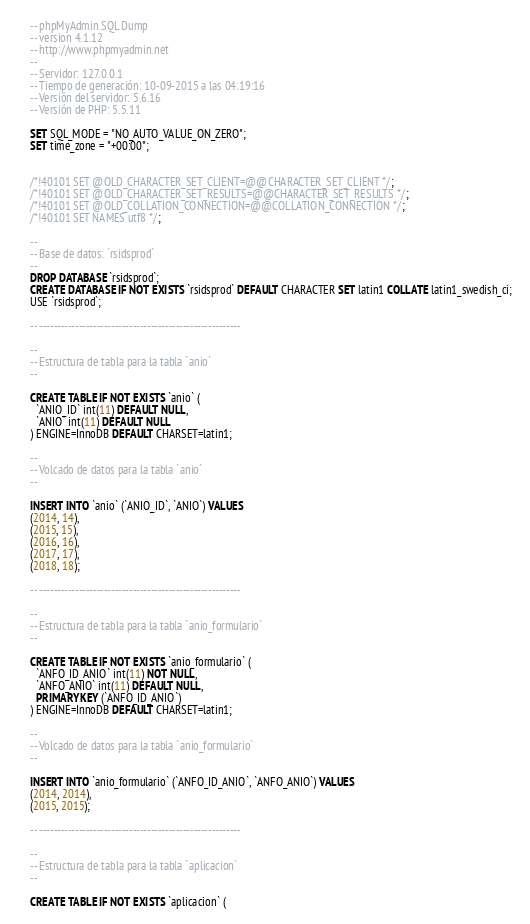<code> <loc_0><loc_0><loc_500><loc_500><_SQL_>-- phpMyAdmin SQL Dump
-- version 4.1.12
-- http://www.phpmyadmin.net
--
-- Servidor: 127.0.0.1
-- Tiempo de generación: 10-09-2015 a las 04:19:16
-- Versión del servidor: 5.6.16
-- Versión de PHP: 5.5.11

SET SQL_MODE = "NO_AUTO_VALUE_ON_ZERO";
SET time_zone = "+00:00";


/*!40101 SET @OLD_CHARACTER_SET_CLIENT=@@CHARACTER_SET_CLIENT */;
/*!40101 SET @OLD_CHARACTER_SET_RESULTS=@@CHARACTER_SET_RESULTS */;
/*!40101 SET @OLD_COLLATION_CONNECTION=@@COLLATION_CONNECTION */;
/*!40101 SET NAMES utf8 */;

--
-- Base de datos: `rsidsprod`
--
DROP DATABASE `rsidsprod`;
CREATE DATABASE IF NOT EXISTS `rsidsprod` DEFAULT CHARACTER SET latin1 COLLATE latin1_swedish_ci;
USE `rsidsprod`;

-- --------------------------------------------------------

--
-- Estructura de tabla para la tabla `anio`
--

CREATE TABLE IF NOT EXISTS `anio` (
  `ANIO_ID` int(11) DEFAULT NULL,
  `ANIO` int(11) DEFAULT NULL
) ENGINE=InnoDB DEFAULT CHARSET=latin1;

--
-- Volcado de datos para la tabla `anio`
--

INSERT INTO `anio` (`ANIO_ID`, `ANIO`) VALUES
(2014, 14),
(2015, 15),
(2016, 16),
(2017, 17),
(2018, 18);

-- --------------------------------------------------------

--
-- Estructura de tabla para la tabla `anio_formulario`
--

CREATE TABLE IF NOT EXISTS `anio_formulario` (
  `ANFO_ID_ANIO` int(11) NOT NULL,
  `ANFO_ANIO` int(11) DEFAULT NULL,
  PRIMARY KEY (`ANFO_ID_ANIO`)
) ENGINE=InnoDB DEFAULT CHARSET=latin1;

--
-- Volcado de datos para la tabla `anio_formulario`
--

INSERT INTO `anio_formulario` (`ANFO_ID_ANIO`, `ANFO_ANIO`) VALUES
(2014, 2014),
(2015, 2015);

-- --------------------------------------------------------

--
-- Estructura de tabla para la tabla `aplicacion`
--

CREATE TABLE IF NOT EXISTS `aplicacion` (</code> 